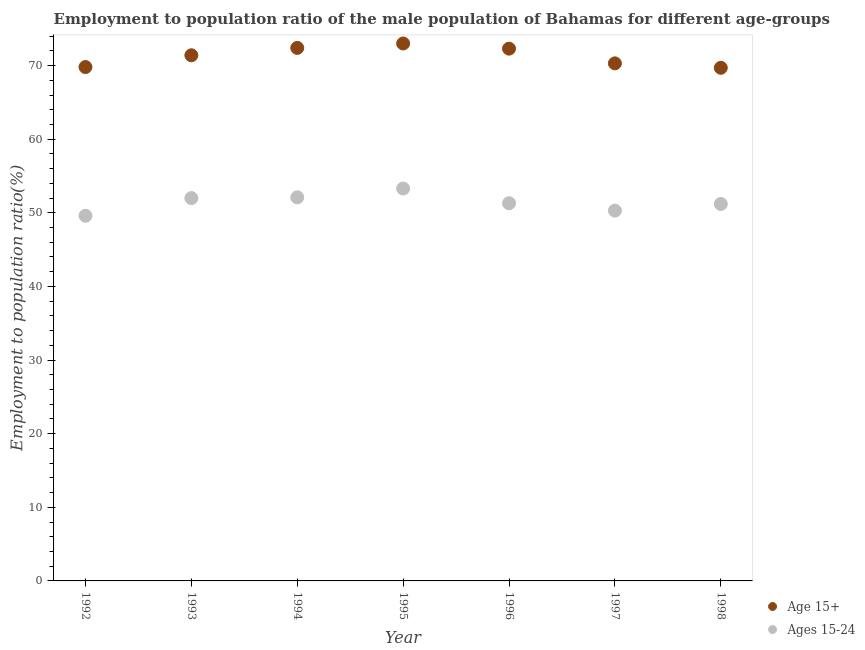What is the employment to population ratio(age 15-24) in 1995?
Make the answer very short. 53.3. Across all years, what is the maximum employment to population ratio(age 15-24)?
Make the answer very short. 53.3. Across all years, what is the minimum employment to population ratio(age 15-24)?
Ensure brevity in your answer.  49.6. In which year was the employment to population ratio(age 15+) maximum?
Offer a terse response. 1995. What is the total employment to population ratio(age 15-24) in the graph?
Give a very brief answer. 359.8. What is the difference between the employment to population ratio(age 15-24) in 1997 and that in 1998?
Provide a succinct answer. -0.9. What is the difference between the employment to population ratio(age 15+) in 1996 and the employment to population ratio(age 15-24) in 1995?
Ensure brevity in your answer.  19. What is the average employment to population ratio(age 15-24) per year?
Your response must be concise. 51.4. In the year 1997, what is the difference between the employment to population ratio(age 15+) and employment to population ratio(age 15-24)?
Your answer should be very brief. 20. What is the ratio of the employment to population ratio(age 15-24) in 1993 to that in 1997?
Provide a succinct answer. 1.03. Is the employment to population ratio(age 15-24) in 1993 less than that in 1997?
Make the answer very short. No. What is the difference between the highest and the second highest employment to population ratio(age 15-24)?
Offer a terse response. 1.2. What is the difference between the highest and the lowest employment to population ratio(age 15+)?
Offer a very short reply. 3.3. In how many years, is the employment to population ratio(age 15+) greater than the average employment to population ratio(age 15+) taken over all years?
Your answer should be very brief. 4. Is the sum of the employment to population ratio(age 15+) in 1992 and 1993 greater than the maximum employment to population ratio(age 15-24) across all years?
Offer a very short reply. Yes. Is the employment to population ratio(age 15-24) strictly greater than the employment to population ratio(age 15+) over the years?
Make the answer very short. No. What is the difference between two consecutive major ticks on the Y-axis?
Offer a terse response. 10. Does the graph contain any zero values?
Provide a short and direct response. No. How many legend labels are there?
Your response must be concise. 2. How are the legend labels stacked?
Keep it short and to the point. Vertical. What is the title of the graph?
Offer a very short reply. Employment to population ratio of the male population of Bahamas for different age-groups. What is the Employment to population ratio(%) of Age 15+ in 1992?
Ensure brevity in your answer.  69.8. What is the Employment to population ratio(%) in Ages 15-24 in 1992?
Provide a short and direct response. 49.6. What is the Employment to population ratio(%) of Age 15+ in 1993?
Ensure brevity in your answer.  71.4. What is the Employment to population ratio(%) in Ages 15-24 in 1993?
Your answer should be compact. 52. What is the Employment to population ratio(%) in Age 15+ in 1994?
Provide a short and direct response. 72.4. What is the Employment to population ratio(%) in Ages 15-24 in 1994?
Offer a terse response. 52.1. What is the Employment to population ratio(%) of Ages 15-24 in 1995?
Give a very brief answer. 53.3. What is the Employment to population ratio(%) in Age 15+ in 1996?
Offer a terse response. 72.3. What is the Employment to population ratio(%) in Ages 15-24 in 1996?
Your answer should be compact. 51.3. What is the Employment to population ratio(%) of Age 15+ in 1997?
Provide a short and direct response. 70.3. What is the Employment to population ratio(%) in Ages 15-24 in 1997?
Your response must be concise. 50.3. What is the Employment to population ratio(%) of Age 15+ in 1998?
Provide a short and direct response. 69.7. What is the Employment to population ratio(%) of Ages 15-24 in 1998?
Your response must be concise. 51.2. Across all years, what is the maximum Employment to population ratio(%) in Age 15+?
Your answer should be very brief. 73. Across all years, what is the maximum Employment to population ratio(%) in Ages 15-24?
Offer a terse response. 53.3. Across all years, what is the minimum Employment to population ratio(%) in Age 15+?
Offer a very short reply. 69.7. Across all years, what is the minimum Employment to population ratio(%) of Ages 15-24?
Provide a succinct answer. 49.6. What is the total Employment to population ratio(%) of Age 15+ in the graph?
Keep it short and to the point. 498.9. What is the total Employment to population ratio(%) of Ages 15-24 in the graph?
Your response must be concise. 359.8. What is the difference between the Employment to population ratio(%) in Ages 15-24 in 1992 and that in 1993?
Give a very brief answer. -2.4. What is the difference between the Employment to population ratio(%) of Age 15+ in 1992 and that in 1994?
Keep it short and to the point. -2.6. What is the difference between the Employment to population ratio(%) in Ages 15-24 in 1992 and that in 1995?
Offer a very short reply. -3.7. What is the difference between the Employment to population ratio(%) in Ages 15-24 in 1992 and that in 1996?
Your answer should be very brief. -1.7. What is the difference between the Employment to population ratio(%) of Age 15+ in 1992 and that in 1998?
Your answer should be very brief. 0.1. What is the difference between the Employment to population ratio(%) in Ages 15-24 in 1992 and that in 1998?
Give a very brief answer. -1.6. What is the difference between the Employment to population ratio(%) in Age 15+ in 1993 and that in 1996?
Offer a terse response. -0.9. What is the difference between the Employment to population ratio(%) of Ages 15-24 in 1993 and that in 1997?
Offer a terse response. 1.7. What is the difference between the Employment to population ratio(%) of Age 15+ in 1993 and that in 1998?
Ensure brevity in your answer.  1.7. What is the difference between the Employment to population ratio(%) of Ages 15-24 in 1994 and that in 1995?
Your answer should be very brief. -1.2. What is the difference between the Employment to population ratio(%) in Age 15+ in 1994 and that in 1996?
Provide a short and direct response. 0.1. What is the difference between the Employment to population ratio(%) in Age 15+ in 1994 and that in 1997?
Ensure brevity in your answer.  2.1. What is the difference between the Employment to population ratio(%) in Ages 15-24 in 1995 and that in 1996?
Provide a short and direct response. 2. What is the difference between the Employment to population ratio(%) in Age 15+ in 1995 and that in 1997?
Keep it short and to the point. 2.7. What is the difference between the Employment to population ratio(%) in Ages 15-24 in 1995 and that in 1997?
Provide a succinct answer. 3. What is the difference between the Employment to population ratio(%) in Age 15+ in 1995 and that in 1998?
Provide a short and direct response. 3.3. What is the difference between the Employment to population ratio(%) of Ages 15-24 in 1995 and that in 1998?
Ensure brevity in your answer.  2.1. What is the difference between the Employment to population ratio(%) in Age 15+ in 1996 and that in 1997?
Keep it short and to the point. 2. What is the difference between the Employment to population ratio(%) in Ages 15-24 in 1996 and that in 1997?
Your answer should be very brief. 1. What is the difference between the Employment to population ratio(%) in Age 15+ in 1996 and that in 1998?
Keep it short and to the point. 2.6. What is the difference between the Employment to population ratio(%) of Age 15+ in 1997 and that in 1998?
Your answer should be compact. 0.6. What is the difference between the Employment to population ratio(%) in Ages 15-24 in 1997 and that in 1998?
Keep it short and to the point. -0.9. What is the difference between the Employment to population ratio(%) of Age 15+ in 1992 and the Employment to population ratio(%) of Ages 15-24 in 1994?
Provide a succinct answer. 17.7. What is the difference between the Employment to population ratio(%) in Age 15+ in 1992 and the Employment to population ratio(%) in Ages 15-24 in 1995?
Give a very brief answer. 16.5. What is the difference between the Employment to population ratio(%) in Age 15+ in 1992 and the Employment to population ratio(%) in Ages 15-24 in 1998?
Provide a succinct answer. 18.6. What is the difference between the Employment to population ratio(%) in Age 15+ in 1993 and the Employment to population ratio(%) in Ages 15-24 in 1994?
Offer a very short reply. 19.3. What is the difference between the Employment to population ratio(%) of Age 15+ in 1993 and the Employment to population ratio(%) of Ages 15-24 in 1996?
Offer a terse response. 20.1. What is the difference between the Employment to population ratio(%) in Age 15+ in 1993 and the Employment to population ratio(%) in Ages 15-24 in 1997?
Offer a very short reply. 21.1. What is the difference between the Employment to population ratio(%) of Age 15+ in 1993 and the Employment to population ratio(%) of Ages 15-24 in 1998?
Ensure brevity in your answer.  20.2. What is the difference between the Employment to population ratio(%) of Age 15+ in 1994 and the Employment to population ratio(%) of Ages 15-24 in 1995?
Make the answer very short. 19.1. What is the difference between the Employment to population ratio(%) of Age 15+ in 1994 and the Employment to population ratio(%) of Ages 15-24 in 1996?
Ensure brevity in your answer.  21.1. What is the difference between the Employment to population ratio(%) of Age 15+ in 1994 and the Employment to population ratio(%) of Ages 15-24 in 1997?
Offer a terse response. 22.1. What is the difference between the Employment to population ratio(%) in Age 15+ in 1994 and the Employment to population ratio(%) in Ages 15-24 in 1998?
Provide a short and direct response. 21.2. What is the difference between the Employment to population ratio(%) of Age 15+ in 1995 and the Employment to population ratio(%) of Ages 15-24 in 1996?
Keep it short and to the point. 21.7. What is the difference between the Employment to population ratio(%) in Age 15+ in 1995 and the Employment to population ratio(%) in Ages 15-24 in 1997?
Provide a short and direct response. 22.7. What is the difference between the Employment to population ratio(%) in Age 15+ in 1995 and the Employment to population ratio(%) in Ages 15-24 in 1998?
Give a very brief answer. 21.8. What is the difference between the Employment to population ratio(%) of Age 15+ in 1996 and the Employment to population ratio(%) of Ages 15-24 in 1997?
Ensure brevity in your answer.  22. What is the difference between the Employment to population ratio(%) of Age 15+ in 1996 and the Employment to population ratio(%) of Ages 15-24 in 1998?
Provide a succinct answer. 21.1. What is the difference between the Employment to population ratio(%) in Age 15+ in 1997 and the Employment to population ratio(%) in Ages 15-24 in 1998?
Give a very brief answer. 19.1. What is the average Employment to population ratio(%) of Age 15+ per year?
Provide a succinct answer. 71.27. What is the average Employment to population ratio(%) of Ages 15-24 per year?
Offer a very short reply. 51.4. In the year 1992, what is the difference between the Employment to population ratio(%) in Age 15+ and Employment to population ratio(%) in Ages 15-24?
Keep it short and to the point. 20.2. In the year 1994, what is the difference between the Employment to population ratio(%) of Age 15+ and Employment to population ratio(%) of Ages 15-24?
Ensure brevity in your answer.  20.3. In the year 1995, what is the difference between the Employment to population ratio(%) of Age 15+ and Employment to population ratio(%) of Ages 15-24?
Your answer should be compact. 19.7. What is the ratio of the Employment to population ratio(%) in Age 15+ in 1992 to that in 1993?
Provide a short and direct response. 0.98. What is the ratio of the Employment to population ratio(%) in Ages 15-24 in 1992 to that in 1993?
Ensure brevity in your answer.  0.95. What is the ratio of the Employment to population ratio(%) in Age 15+ in 1992 to that in 1994?
Keep it short and to the point. 0.96. What is the ratio of the Employment to population ratio(%) of Ages 15-24 in 1992 to that in 1994?
Your response must be concise. 0.95. What is the ratio of the Employment to population ratio(%) in Age 15+ in 1992 to that in 1995?
Keep it short and to the point. 0.96. What is the ratio of the Employment to population ratio(%) in Ages 15-24 in 1992 to that in 1995?
Your response must be concise. 0.93. What is the ratio of the Employment to population ratio(%) of Age 15+ in 1992 to that in 1996?
Offer a terse response. 0.97. What is the ratio of the Employment to population ratio(%) of Ages 15-24 in 1992 to that in 1996?
Provide a succinct answer. 0.97. What is the ratio of the Employment to population ratio(%) of Age 15+ in 1992 to that in 1997?
Offer a very short reply. 0.99. What is the ratio of the Employment to population ratio(%) of Ages 15-24 in 1992 to that in 1997?
Keep it short and to the point. 0.99. What is the ratio of the Employment to population ratio(%) in Age 15+ in 1992 to that in 1998?
Provide a short and direct response. 1. What is the ratio of the Employment to population ratio(%) in Ages 15-24 in 1992 to that in 1998?
Offer a very short reply. 0.97. What is the ratio of the Employment to population ratio(%) in Age 15+ in 1993 to that in 1994?
Keep it short and to the point. 0.99. What is the ratio of the Employment to population ratio(%) of Age 15+ in 1993 to that in 1995?
Make the answer very short. 0.98. What is the ratio of the Employment to population ratio(%) of Ages 15-24 in 1993 to that in 1995?
Offer a very short reply. 0.98. What is the ratio of the Employment to population ratio(%) in Age 15+ in 1993 to that in 1996?
Offer a very short reply. 0.99. What is the ratio of the Employment to population ratio(%) of Ages 15-24 in 1993 to that in 1996?
Keep it short and to the point. 1.01. What is the ratio of the Employment to population ratio(%) of Age 15+ in 1993 to that in 1997?
Give a very brief answer. 1.02. What is the ratio of the Employment to population ratio(%) in Ages 15-24 in 1993 to that in 1997?
Ensure brevity in your answer.  1.03. What is the ratio of the Employment to population ratio(%) of Age 15+ in 1993 to that in 1998?
Keep it short and to the point. 1.02. What is the ratio of the Employment to population ratio(%) of Ages 15-24 in 1993 to that in 1998?
Provide a short and direct response. 1.02. What is the ratio of the Employment to population ratio(%) of Age 15+ in 1994 to that in 1995?
Give a very brief answer. 0.99. What is the ratio of the Employment to population ratio(%) of Ages 15-24 in 1994 to that in 1995?
Provide a succinct answer. 0.98. What is the ratio of the Employment to population ratio(%) of Ages 15-24 in 1994 to that in 1996?
Offer a terse response. 1.02. What is the ratio of the Employment to population ratio(%) of Age 15+ in 1994 to that in 1997?
Keep it short and to the point. 1.03. What is the ratio of the Employment to population ratio(%) in Ages 15-24 in 1994 to that in 1997?
Provide a succinct answer. 1.04. What is the ratio of the Employment to population ratio(%) of Age 15+ in 1994 to that in 1998?
Keep it short and to the point. 1.04. What is the ratio of the Employment to population ratio(%) in Ages 15-24 in 1994 to that in 1998?
Provide a short and direct response. 1.02. What is the ratio of the Employment to population ratio(%) in Age 15+ in 1995 to that in 1996?
Keep it short and to the point. 1.01. What is the ratio of the Employment to population ratio(%) of Ages 15-24 in 1995 to that in 1996?
Your answer should be very brief. 1.04. What is the ratio of the Employment to population ratio(%) of Age 15+ in 1995 to that in 1997?
Provide a succinct answer. 1.04. What is the ratio of the Employment to population ratio(%) of Ages 15-24 in 1995 to that in 1997?
Offer a very short reply. 1.06. What is the ratio of the Employment to population ratio(%) in Age 15+ in 1995 to that in 1998?
Make the answer very short. 1.05. What is the ratio of the Employment to population ratio(%) of Ages 15-24 in 1995 to that in 1998?
Your answer should be very brief. 1.04. What is the ratio of the Employment to population ratio(%) in Age 15+ in 1996 to that in 1997?
Give a very brief answer. 1.03. What is the ratio of the Employment to population ratio(%) of Ages 15-24 in 1996 to that in 1997?
Keep it short and to the point. 1.02. What is the ratio of the Employment to population ratio(%) in Age 15+ in 1996 to that in 1998?
Keep it short and to the point. 1.04. What is the ratio of the Employment to population ratio(%) in Ages 15-24 in 1996 to that in 1998?
Offer a terse response. 1. What is the ratio of the Employment to population ratio(%) of Age 15+ in 1997 to that in 1998?
Your response must be concise. 1.01. What is the ratio of the Employment to population ratio(%) of Ages 15-24 in 1997 to that in 1998?
Your response must be concise. 0.98. What is the difference between the highest and the lowest Employment to population ratio(%) of Age 15+?
Make the answer very short. 3.3. 